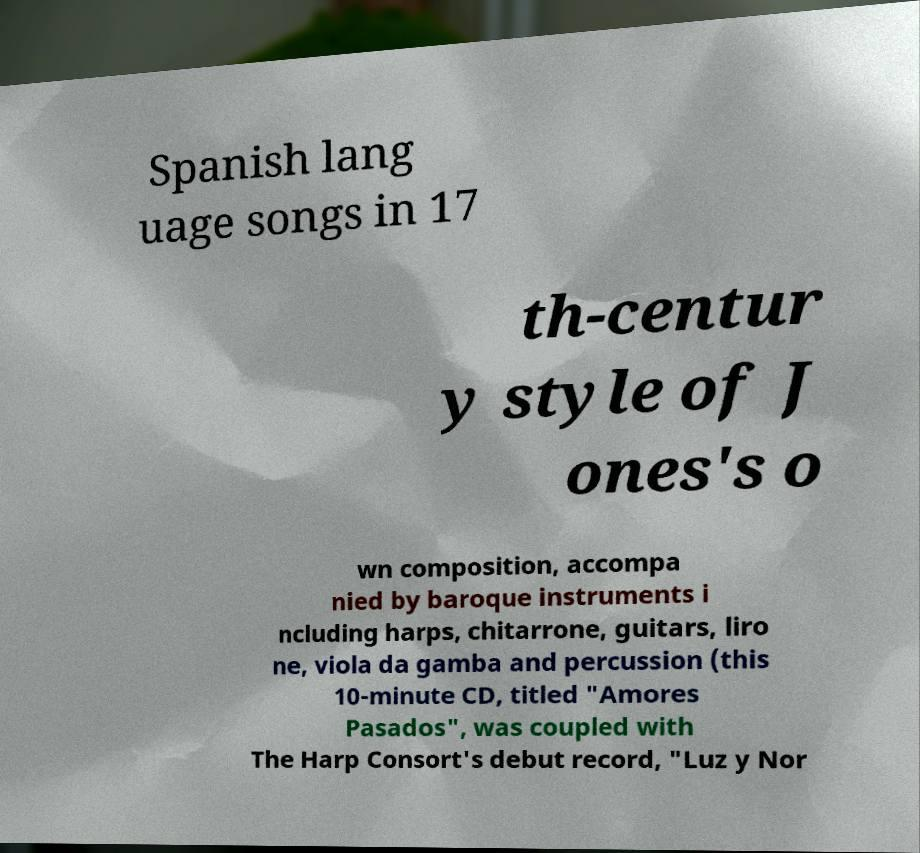Could you extract and type out the text from this image? Spanish lang uage songs in 17 th-centur y style of J ones's o wn composition, accompa nied by baroque instruments i ncluding harps, chitarrone, guitars, liro ne, viola da gamba and percussion (this 10-minute CD, titled "Amores Pasados", was coupled with The Harp Consort's debut record, "Luz y Nor 